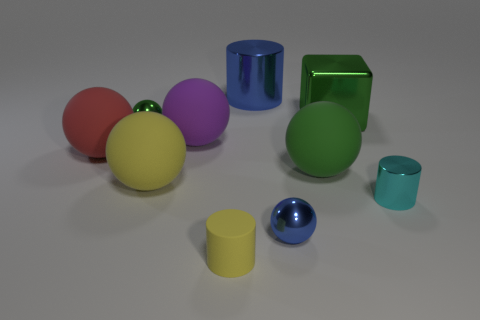What material is the red thing that is the same shape as the purple thing?
Give a very brief answer. Rubber. How many things are cylinders in front of the large green metallic object or rubber spheres right of the tiny blue ball?
Keep it short and to the point. 3. There is a green thing that is both in front of the green cube and right of the big purple rubber object; what is its shape?
Your response must be concise. Sphere. There is a small metal sphere that is to the left of the tiny yellow matte thing; how many big matte balls are behind it?
Provide a succinct answer. 0. Is there anything else that has the same material as the tiny blue thing?
Give a very brief answer. Yes. How many objects are things behind the small blue sphere or big purple matte objects?
Provide a short and direct response. 8. There is a metal ball that is behind the cyan cylinder; what size is it?
Provide a succinct answer. Small. What material is the red thing?
Your answer should be very brief. Rubber. The small metal object left of the metal ball that is in front of the green metal ball is what shape?
Offer a very short reply. Sphere. How many other things are the same shape as the tiny yellow thing?
Make the answer very short. 2. 